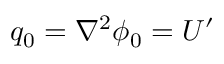<formula> <loc_0><loc_0><loc_500><loc_500>q _ { 0 } = \nabla ^ { 2 } \phi _ { 0 } = U ^ { \prime }</formula> 